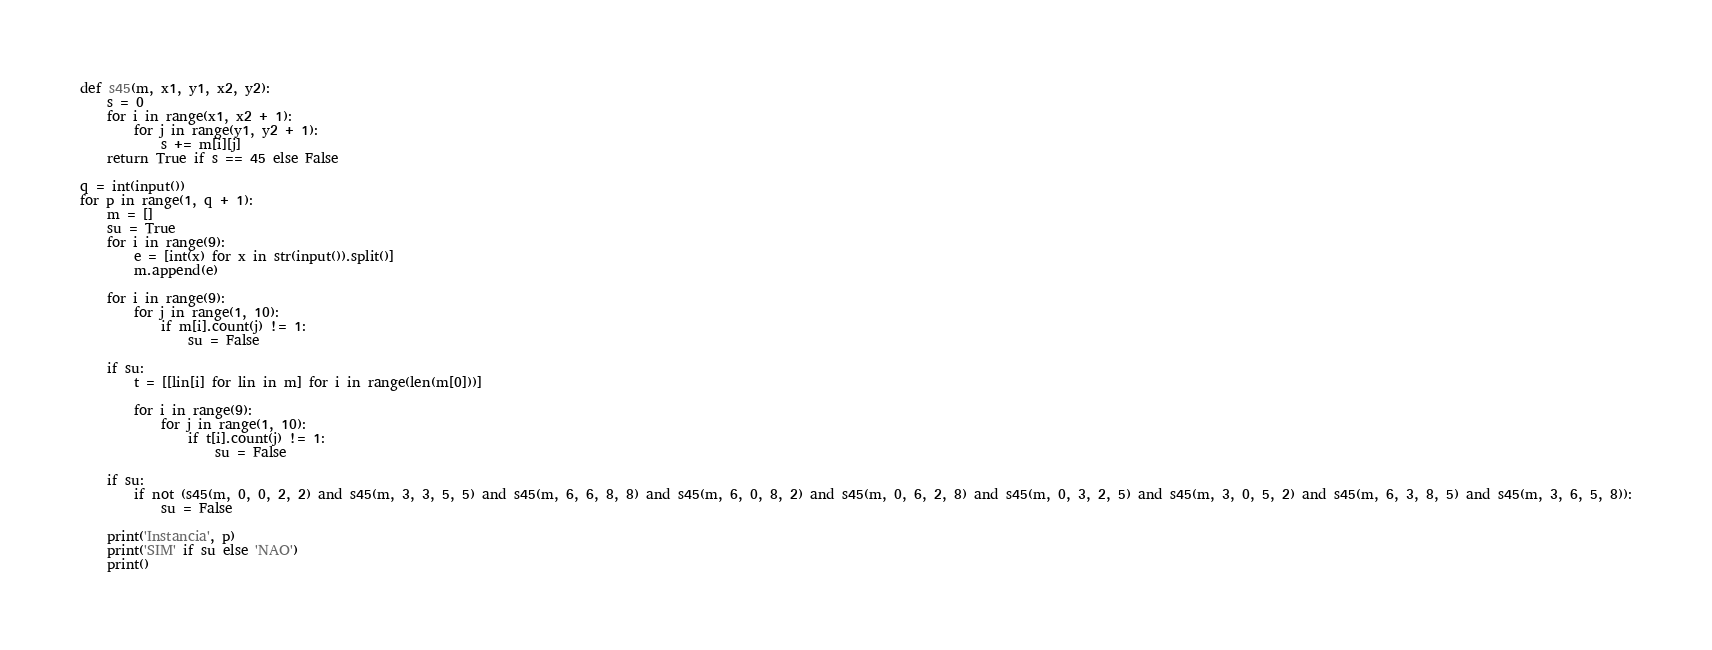<code> <loc_0><loc_0><loc_500><loc_500><_Python_>def s45(m, x1, y1, x2, y2):
    s = 0
    for i in range(x1, x2 + 1):
        for j in range(y1, y2 + 1):
            s += m[i][j]
    return True if s == 45 else False

q = int(input())
for p in range(1, q + 1):
    m = []
    su = True
    for i in range(9):
        e = [int(x) for x in str(input()).split()]
        m.append(e)

    for i in range(9):
        for j in range(1, 10):
            if m[i].count(j) != 1:
                su = False

    if su:
        t = [[lin[i] for lin in m] for i in range(len(m[0]))]

        for i in range(9):
            for j in range(1, 10):
                if t[i].count(j) != 1:
                    su = False

    if su:
        if not (s45(m, 0, 0, 2, 2) and s45(m, 3, 3, 5, 5) and s45(m, 6, 6, 8, 8) and s45(m, 6, 0, 8, 2) and s45(m, 0, 6, 2, 8) and s45(m, 0, 3, 2, 5) and s45(m, 3, 0, 5, 2) and s45(m, 6, 3, 8, 5) and s45(m, 3, 6, 5, 8)):
            su = False

    print('Instancia', p)
    print('SIM' if su else 'NAO')
    print()
</code> 